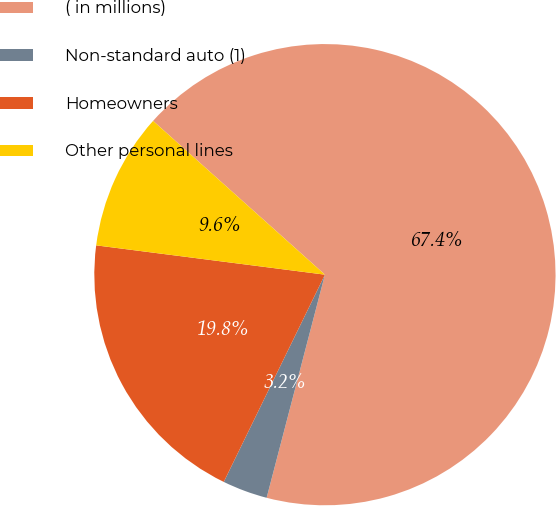<chart> <loc_0><loc_0><loc_500><loc_500><pie_chart><fcel>( in millions)<fcel>Non-standard auto (1)<fcel>Homeowners<fcel>Other personal lines<nl><fcel>67.45%<fcel>3.16%<fcel>19.8%<fcel>9.59%<nl></chart> 